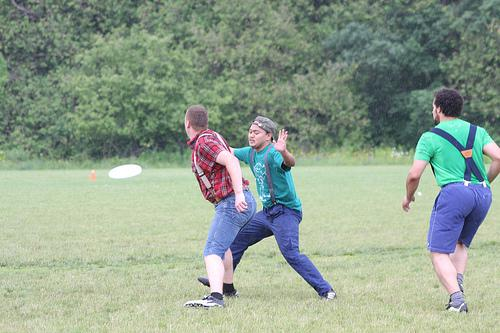Question: what are they throwing?
Choices:
A. Baseballs.
B. Tennis balls.
C. Frisbee.
D. Knives.
Answer with the letter. Answer: C Question: what color are the men's shorts?
Choices:
A. Grey.
B. White.
C. Black.
D. Blue.
Answer with the letter. Answer: D Question: what patter is on the man's red shirt?
Choices:
A. Stripes.
B. Dots.
C. Zig zags.
D. Plaid.
Answer with the letter. Answer: D Question: who is wearing a green shirt?
Choices:
A. Woman behind the couch.
B. Child on the chair.
C. Man on the far right.
D. Man on the left.
Answer with the letter. Answer: C Question: where are the playing?
Choices:
A. Grass.
B. Stage.
C. Outside.
D. In the parking lot.
Answer with the letter. Answer: A Question: how many men are there?
Choices:
A. One.
B. Four.
C. Three.
D. Two.
Answer with the letter. Answer: C 